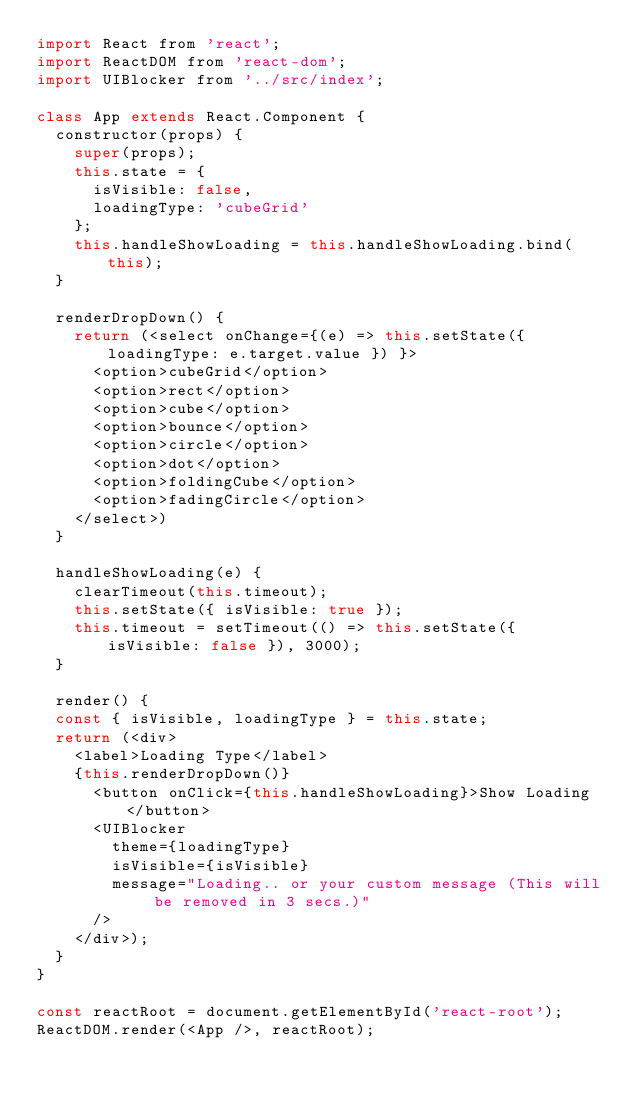<code> <loc_0><loc_0><loc_500><loc_500><_JavaScript_>import React from 'react';
import ReactDOM from 'react-dom';
import UIBlocker from '../src/index';

class App extends React.Component {
  constructor(props) {
    super(props);
    this.state = {
      isVisible: false,
      loadingType: 'cubeGrid'
    };
    this.handleShowLoading = this.handleShowLoading.bind(this);
  }

  renderDropDown() {
    return (<select onChange={(e) => this.setState({ loadingType: e.target.value }) }>
      <option>cubeGrid</option>
      <option>rect</option>
      <option>cube</option>
      <option>bounce</option>
      <option>circle</option>
      <option>dot</option>
      <option>foldingCube</option>
      <option>fadingCircle</option>
    </select>)
  }

  handleShowLoading(e) {
    clearTimeout(this.timeout);
    this.setState({ isVisible: true });
    this.timeout = setTimeout(() => this.setState({ isVisible: false }), 3000);
  }

  render() {
  const { isVisible, loadingType } = this.state;
  return (<div>
    <label>Loading Type</label> 
    {this.renderDropDown()}
      <button onClick={this.handleShowLoading}>Show Loading</button>
      <UIBlocker
        theme={loadingType}
        isVisible={isVisible}
        message="Loading.. or your custom message (This will be removed in 3 secs.)"
      />
    </div>);
  }
}

const reactRoot = document.getElementById('react-root');
ReactDOM.render(<App />, reactRoot);</code> 